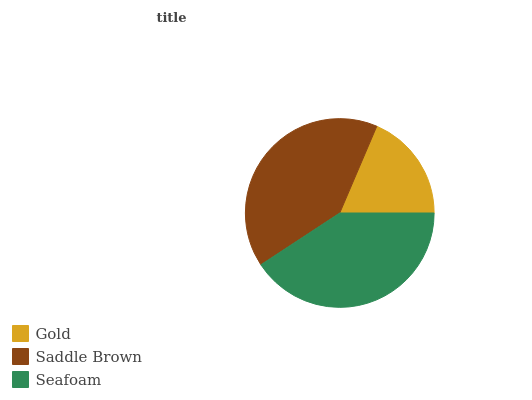Is Gold the minimum?
Answer yes or no. Yes. Is Seafoam the maximum?
Answer yes or no. Yes. Is Saddle Brown the minimum?
Answer yes or no. No. Is Saddle Brown the maximum?
Answer yes or no. No. Is Saddle Brown greater than Gold?
Answer yes or no. Yes. Is Gold less than Saddle Brown?
Answer yes or no. Yes. Is Gold greater than Saddle Brown?
Answer yes or no. No. Is Saddle Brown less than Gold?
Answer yes or no. No. Is Saddle Brown the high median?
Answer yes or no. Yes. Is Saddle Brown the low median?
Answer yes or no. Yes. Is Gold the high median?
Answer yes or no. No. Is Gold the low median?
Answer yes or no. No. 